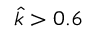Convert formula to latex. <formula><loc_0><loc_0><loc_500><loc_500>\hat { k } > 0 . 6</formula> 